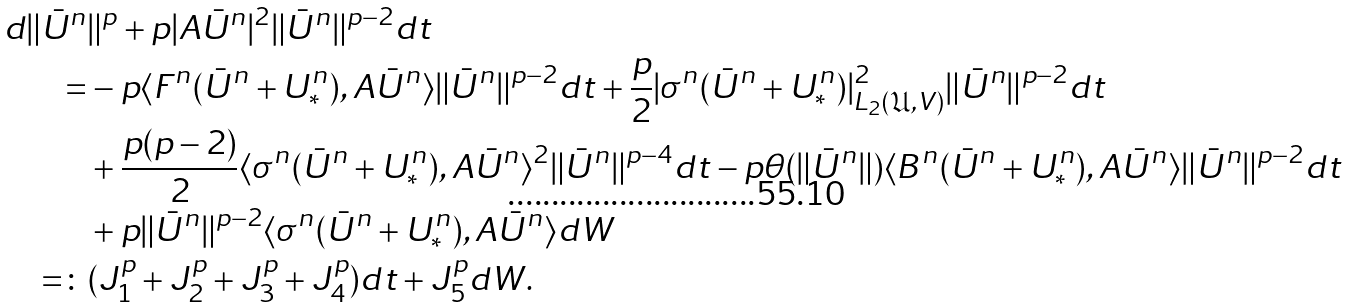<formula> <loc_0><loc_0><loc_500><loc_500>d \| \bar { U } ^ { n } & \| ^ { p } + p | A \bar { U } ^ { n } | ^ { 2 } \| \bar { U } ^ { n } \| ^ { p - 2 } d t \\ = & - p \langle F ^ { n } ( \bar { U } ^ { n } + U ^ { n } _ { * } ) , A \bar { U } ^ { n } \rangle \| \bar { U } ^ { n } \| ^ { p - 2 } d t + \frac { p } { 2 } | \sigma ^ { n } ( \bar { U } ^ { n } + U ^ { n } _ { * } ) | ^ { 2 } _ { L _ { 2 } ( \mathfrak { U } , V ) } \| \bar { U } ^ { n } \| ^ { p - 2 } d t \\ & + \frac { p ( p - 2 ) } { 2 } \langle \sigma ^ { n } ( \bar { U } ^ { n } + U ^ { n } _ { * } ) , A \bar { U } ^ { n } \rangle ^ { 2 } \| \bar { U } ^ { n } \| ^ { p - 4 } d t - p \theta ( \| \bar { U } ^ { n } \| ) \langle B ^ { n } ( \bar { U } ^ { n } + U ^ { n } _ { * } ) , A \bar { U } ^ { n } \rangle \| \bar { U } ^ { n } \| ^ { p - 2 } d t \\ & + p \| \bar { U } ^ { n } \| ^ { p - 2 } \langle \sigma ^ { n } ( \bar { U } ^ { n } + U ^ { n } _ { * } ) , A \bar { U } ^ { n } \rangle d W \\ = \colon & ( J _ { 1 } ^ { p } + J _ { 2 } ^ { p } + J _ { 3 } ^ { p } + J _ { 4 } ^ { p } ) d t + J _ { 5 } ^ { p } d W .</formula> 